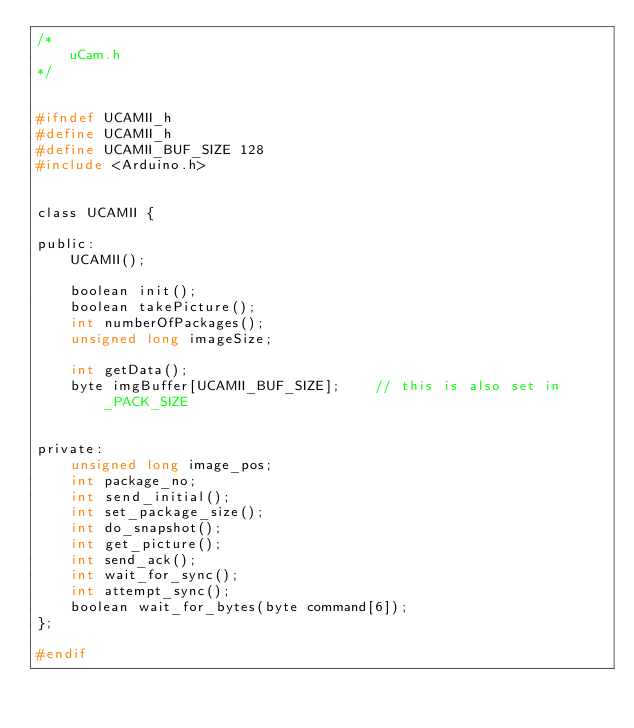Convert code to text. <code><loc_0><loc_0><loc_500><loc_500><_C_>/*
    uCam.h  
*/


#ifndef UCAMII_h
#define UCAMII_h
#define UCAMII_BUF_SIZE 128
#include <Arduino.h>


class UCAMII {

public:
    UCAMII();

    boolean init();
    boolean takePicture();
    int numberOfPackages();    
    unsigned long imageSize;

    int getData();    
    byte imgBuffer[UCAMII_BUF_SIZE];    // this is also set in _PACK_SIZE

    
private:
    unsigned long image_pos;
    int package_no;
    int send_initial();
    int set_package_size();
    int do_snapshot();
    int get_picture();
    int send_ack();
    int wait_for_sync();
    int attempt_sync();
    boolean wait_for_bytes(byte command[6]);
};

#endif
</code> 